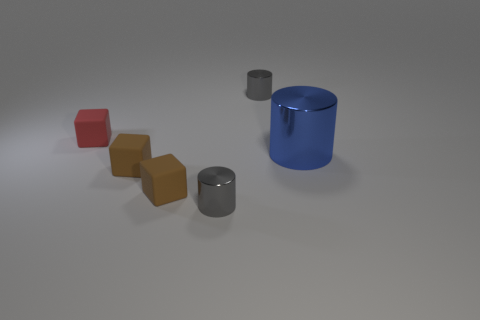How does the light source in the scene affect the appearance of the objects? The light source illuminates the scene from above, casting soft shadows beneath the objects. It accentuates the reflective qualities of the cylindrical objects, which create highlights on their surfaces. The matte finish of the red block absorbs the light, preventing it from reflecting and therefore maintaining a consistent color throughout its surface. 